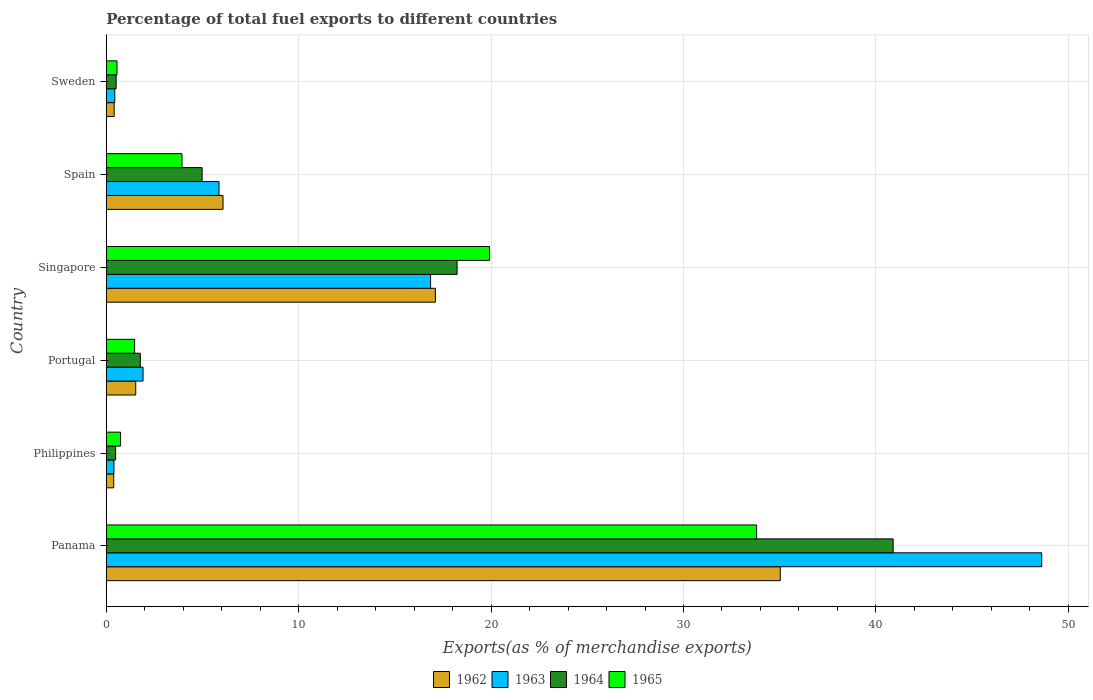How many groups of bars are there?
Offer a very short reply. 6. Are the number of bars per tick equal to the number of legend labels?
Make the answer very short. Yes. How many bars are there on the 5th tick from the bottom?
Keep it short and to the point. 4. What is the label of the 6th group of bars from the top?
Keep it short and to the point. Panama. What is the percentage of exports to different countries in 1963 in Panama?
Offer a very short reply. 48.62. Across all countries, what is the maximum percentage of exports to different countries in 1965?
Ensure brevity in your answer.  33.8. Across all countries, what is the minimum percentage of exports to different countries in 1962?
Ensure brevity in your answer.  0.38. In which country was the percentage of exports to different countries in 1962 maximum?
Your response must be concise. Panama. What is the total percentage of exports to different countries in 1965 in the graph?
Offer a very short reply. 60.42. What is the difference between the percentage of exports to different countries in 1964 in Portugal and that in Singapore?
Ensure brevity in your answer.  -16.47. What is the difference between the percentage of exports to different countries in 1962 in Panama and the percentage of exports to different countries in 1963 in Spain?
Give a very brief answer. 29.17. What is the average percentage of exports to different countries in 1962 per country?
Provide a short and direct response. 10.09. What is the difference between the percentage of exports to different countries in 1964 and percentage of exports to different countries in 1965 in Singapore?
Offer a very short reply. -1.69. What is the ratio of the percentage of exports to different countries in 1964 in Philippines to that in Singapore?
Give a very brief answer. 0.03. Is the difference between the percentage of exports to different countries in 1964 in Portugal and Sweden greater than the difference between the percentage of exports to different countries in 1965 in Portugal and Sweden?
Give a very brief answer. Yes. What is the difference between the highest and the second highest percentage of exports to different countries in 1963?
Your answer should be compact. 31.77. What is the difference between the highest and the lowest percentage of exports to different countries in 1962?
Keep it short and to the point. 34.64. In how many countries, is the percentage of exports to different countries in 1965 greater than the average percentage of exports to different countries in 1965 taken over all countries?
Provide a short and direct response. 2. Is it the case that in every country, the sum of the percentage of exports to different countries in 1964 and percentage of exports to different countries in 1963 is greater than the sum of percentage of exports to different countries in 1965 and percentage of exports to different countries in 1962?
Your answer should be compact. No. What does the 3rd bar from the top in Panama represents?
Provide a succinct answer. 1963. What does the 4th bar from the bottom in Portugal represents?
Your answer should be very brief. 1965. Is it the case that in every country, the sum of the percentage of exports to different countries in 1964 and percentage of exports to different countries in 1963 is greater than the percentage of exports to different countries in 1962?
Provide a succinct answer. Yes. How many bars are there?
Your response must be concise. 24. What is the difference between two consecutive major ticks on the X-axis?
Your response must be concise. 10. Are the values on the major ticks of X-axis written in scientific E-notation?
Your response must be concise. No. Does the graph contain any zero values?
Provide a succinct answer. No. Does the graph contain grids?
Give a very brief answer. Yes. How are the legend labels stacked?
Provide a short and direct response. Horizontal. What is the title of the graph?
Give a very brief answer. Percentage of total fuel exports to different countries. Does "2010" appear as one of the legend labels in the graph?
Keep it short and to the point. No. What is the label or title of the X-axis?
Your answer should be very brief. Exports(as % of merchandise exports). What is the label or title of the Y-axis?
Ensure brevity in your answer.  Country. What is the Exports(as % of merchandise exports) of 1962 in Panama?
Ensure brevity in your answer.  35.03. What is the Exports(as % of merchandise exports) in 1963 in Panama?
Keep it short and to the point. 48.62. What is the Exports(as % of merchandise exports) of 1964 in Panama?
Your answer should be compact. 40.9. What is the Exports(as % of merchandise exports) of 1965 in Panama?
Keep it short and to the point. 33.8. What is the Exports(as % of merchandise exports) in 1962 in Philippines?
Keep it short and to the point. 0.38. What is the Exports(as % of merchandise exports) in 1963 in Philippines?
Provide a short and direct response. 0.4. What is the Exports(as % of merchandise exports) of 1964 in Philippines?
Make the answer very short. 0.48. What is the Exports(as % of merchandise exports) of 1965 in Philippines?
Offer a terse response. 0.74. What is the Exports(as % of merchandise exports) in 1962 in Portugal?
Offer a terse response. 1.53. What is the Exports(as % of merchandise exports) in 1963 in Portugal?
Keep it short and to the point. 1.91. What is the Exports(as % of merchandise exports) in 1964 in Portugal?
Make the answer very short. 1.77. What is the Exports(as % of merchandise exports) of 1965 in Portugal?
Give a very brief answer. 1.47. What is the Exports(as % of merchandise exports) in 1962 in Singapore?
Ensure brevity in your answer.  17.1. What is the Exports(as % of merchandise exports) of 1963 in Singapore?
Keep it short and to the point. 16.85. What is the Exports(as % of merchandise exports) of 1964 in Singapore?
Your response must be concise. 18.23. What is the Exports(as % of merchandise exports) in 1965 in Singapore?
Provide a short and direct response. 19.92. What is the Exports(as % of merchandise exports) of 1962 in Spain?
Make the answer very short. 6.07. What is the Exports(as % of merchandise exports) of 1963 in Spain?
Make the answer very short. 5.86. What is the Exports(as % of merchandise exports) of 1964 in Spain?
Your answer should be very brief. 4.98. What is the Exports(as % of merchandise exports) of 1965 in Spain?
Keep it short and to the point. 3.93. What is the Exports(as % of merchandise exports) of 1962 in Sweden?
Ensure brevity in your answer.  0.41. What is the Exports(as % of merchandise exports) in 1963 in Sweden?
Provide a short and direct response. 0.44. What is the Exports(as % of merchandise exports) of 1964 in Sweden?
Make the answer very short. 0.51. What is the Exports(as % of merchandise exports) of 1965 in Sweden?
Your answer should be compact. 0.55. Across all countries, what is the maximum Exports(as % of merchandise exports) in 1962?
Your answer should be compact. 35.03. Across all countries, what is the maximum Exports(as % of merchandise exports) in 1963?
Provide a succinct answer. 48.62. Across all countries, what is the maximum Exports(as % of merchandise exports) in 1964?
Give a very brief answer. 40.9. Across all countries, what is the maximum Exports(as % of merchandise exports) in 1965?
Keep it short and to the point. 33.8. Across all countries, what is the minimum Exports(as % of merchandise exports) in 1962?
Offer a terse response. 0.38. Across all countries, what is the minimum Exports(as % of merchandise exports) in 1963?
Make the answer very short. 0.4. Across all countries, what is the minimum Exports(as % of merchandise exports) in 1964?
Your answer should be very brief. 0.48. Across all countries, what is the minimum Exports(as % of merchandise exports) of 1965?
Your answer should be very brief. 0.55. What is the total Exports(as % of merchandise exports) of 1962 in the graph?
Make the answer very short. 60.52. What is the total Exports(as % of merchandise exports) of 1963 in the graph?
Your response must be concise. 74.08. What is the total Exports(as % of merchandise exports) of 1964 in the graph?
Your answer should be very brief. 66.87. What is the total Exports(as % of merchandise exports) of 1965 in the graph?
Keep it short and to the point. 60.42. What is the difference between the Exports(as % of merchandise exports) of 1962 in Panama and that in Philippines?
Offer a terse response. 34.65. What is the difference between the Exports(as % of merchandise exports) in 1963 in Panama and that in Philippines?
Keep it short and to the point. 48.22. What is the difference between the Exports(as % of merchandise exports) of 1964 in Panama and that in Philippines?
Offer a very short reply. 40.41. What is the difference between the Exports(as % of merchandise exports) in 1965 in Panama and that in Philippines?
Keep it short and to the point. 33.06. What is the difference between the Exports(as % of merchandise exports) in 1962 in Panama and that in Portugal?
Your answer should be very brief. 33.5. What is the difference between the Exports(as % of merchandise exports) in 1963 in Panama and that in Portugal?
Give a very brief answer. 46.71. What is the difference between the Exports(as % of merchandise exports) in 1964 in Panama and that in Portugal?
Offer a very short reply. 39.13. What is the difference between the Exports(as % of merchandise exports) of 1965 in Panama and that in Portugal?
Make the answer very short. 32.33. What is the difference between the Exports(as % of merchandise exports) in 1962 in Panama and that in Singapore?
Offer a very short reply. 17.93. What is the difference between the Exports(as % of merchandise exports) in 1963 in Panama and that in Singapore?
Your answer should be very brief. 31.77. What is the difference between the Exports(as % of merchandise exports) in 1964 in Panama and that in Singapore?
Offer a very short reply. 22.67. What is the difference between the Exports(as % of merchandise exports) in 1965 in Panama and that in Singapore?
Offer a terse response. 13.88. What is the difference between the Exports(as % of merchandise exports) in 1962 in Panama and that in Spain?
Offer a very short reply. 28.96. What is the difference between the Exports(as % of merchandise exports) of 1963 in Panama and that in Spain?
Your response must be concise. 42.76. What is the difference between the Exports(as % of merchandise exports) in 1964 in Panama and that in Spain?
Your response must be concise. 35.92. What is the difference between the Exports(as % of merchandise exports) of 1965 in Panama and that in Spain?
Ensure brevity in your answer.  29.87. What is the difference between the Exports(as % of merchandise exports) of 1962 in Panama and that in Sweden?
Keep it short and to the point. 34.62. What is the difference between the Exports(as % of merchandise exports) in 1963 in Panama and that in Sweden?
Provide a succinct answer. 48.18. What is the difference between the Exports(as % of merchandise exports) in 1964 in Panama and that in Sweden?
Give a very brief answer. 40.39. What is the difference between the Exports(as % of merchandise exports) in 1965 in Panama and that in Sweden?
Provide a succinct answer. 33.25. What is the difference between the Exports(as % of merchandise exports) of 1962 in Philippines and that in Portugal?
Your response must be concise. -1.14. What is the difference between the Exports(as % of merchandise exports) of 1963 in Philippines and that in Portugal?
Your answer should be very brief. -1.51. What is the difference between the Exports(as % of merchandise exports) of 1964 in Philippines and that in Portugal?
Provide a succinct answer. -1.28. What is the difference between the Exports(as % of merchandise exports) of 1965 in Philippines and that in Portugal?
Keep it short and to the point. -0.73. What is the difference between the Exports(as % of merchandise exports) of 1962 in Philippines and that in Singapore?
Provide a succinct answer. -16.72. What is the difference between the Exports(as % of merchandise exports) of 1963 in Philippines and that in Singapore?
Offer a very short reply. -16.46. What is the difference between the Exports(as % of merchandise exports) in 1964 in Philippines and that in Singapore?
Make the answer very short. -17.75. What is the difference between the Exports(as % of merchandise exports) in 1965 in Philippines and that in Singapore?
Offer a very short reply. -19.18. What is the difference between the Exports(as % of merchandise exports) of 1962 in Philippines and that in Spain?
Keep it short and to the point. -5.68. What is the difference between the Exports(as % of merchandise exports) in 1963 in Philippines and that in Spain?
Your answer should be very brief. -5.46. What is the difference between the Exports(as % of merchandise exports) of 1964 in Philippines and that in Spain?
Keep it short and to the point. -4.49. What is the difference between the Exports(as % of merchandise exports) of 1965 in Philippines and that in Spain?
Your response must be concise. -3.19. What is the difference between the Exports(as % of merchandise exports) of 1962 in Philippines and that in Sweden?
Give a very brief answer. -0.02. What is the difference between the Exports(as % of merchandise exports) of 1963 in Philippines and that in Sweden?
Your answer should be compact. -0.04. What is the difference between the Exports(as % of merchandise exports) in 1964 in Philippines and that in Sweden?
Offer a terse response. -0.03. What is the difference between the Exports(as % of merchandise exports) of 1965 in Philippines and that in Sweden?
Give a very brief answer. 0.19. What is the difference between the Exports(as % of merchandise exports) of 1962 in Portugal and that in Singapore?
Your answer should be very brief. -15.58. What is the difference between the Exports(as % of merchandise exports) of 1963 in Portugal and that in Singapore?
Offer a terse response. -14.95. What is the difference between the Exports(as % of merchandise exports) in 1964 in Portugal and that in Singapore?
Make the answer very short. -16.47. What is the difference between the Exports(as % of merchandise exports) of 1965 in Portugal and that in Singapore?
Your response must be concise. -18.45. What is the difference between the Exports(as % of merchandise exports) in 1962 in Portugal and that in Spain?
Your answer should be very brief. -4.54. What is the difference between the Exports(as % of merchandise exports) in 1963 in Portugal and that in Spain?
Make the answer very short. -3.95. What is the difference between the Exports(as % of merchandise exports) in 1964 in Portugal and that in Spain?
Make the answer very short. -3.21. What is the difference between the Exports(as % of merchandise exports) of 1965 in Portugal and that in Spain?
Offer a very short reply. -2.46. What is the difference between the Exports(as % of merchandise exports) of 1962 in Portugal and that in Sweden?
Provide a short and direct response. 1.12. What is the difference between the Exports(as % of merchandise exports) of 1963 in Portugal and that in Sweden?
Offer a terse response. 1.47. What is the difference between the Exports(as % of merchandise exports) in 1964 in Portugal and that in Sweden?
Your answer should be compact. 1.26. What is the difference between the Exports(as % of merchandise exports) in 1965 in Portugal and that in Sweden?
Offer a very short reply. 0.91. What is the difference between the Exports(as % of merchandise exports) in 1962 in Singapore and that in Spain?
Keep it short and to the point. 11.04. What is the difference between the Exports(as % of merchandise exports) of 1963 in Singapore and that in Spain?
Give a very brief answer. 11. What is the difference between the Exports(as % of merchandise exports) in 1964 in Singapore and that in Spain?
Provide a succinct answer. 13.25. What is the difference between the Exports(as % of merchandise exports) of 1965 in Singapore and that in Spain?
Give a very brief answer. 15.99. What is the difference between the Exports(as % of merchandise exports) in 1962 in Singapore and that in Sweden?
Offer a terse response. 16.7. What is the difference between the Exports(as % of merchandise exports) of 1963 in Singapore and that in Sweden?
Keep it short and to the point. 16.42. What is the difference between the Exports(as % of merchandise exports) in 1964 in Singapore and that in Sweden?
Make the answer very short. 17.72. What is the difference between the Exports(as % of merchandise exports) in 1965 in Singapore and that in Sweden?
Offer a very short reply. 19.37. What is the difference between the Exports(as % of merchandise exports) in 1962 in Spain and that in Sweden?
Provide a short and direct response. 5.66. What is the difference between the Exports(as % of merchandise exports) of 1963 in Spain and that in Sweden?
Offer a very short reply. 5.42. What is the difference between the Exports(as % of merchandise exports) in 1964 in Spain and that in Sweden?
Your answer should be compact. 4.47. What is the difference between the Exports(as % of merchandise exports) of 1965 in Spain and that in Sweden?
Offer a terse response. 3.38. What is the difference between the Exports(as % of merchandise exports) of 1962 in Panama and the Exports(as % of merchandise exports) of 1963 in Philippines?
Provide a short and direct response. 34.63. What is the difference between the Exports(as % of merchandise exports) in 1962 in Panama and the Exports(as % of merchandise exports) in 1964 in Philippines?
Offer a terse response. 34.55. What is the difference between the Exports(as % of merchandise exports) of 1962 in Panama and the Exports(as % of merchandise exports) of 1965 in Philippines?
Ensure brevity in your answer.  34.29. What is the difference between the Exports(as % of merchandise exports) in 1963 in Panama and the Exports(as % of merchandise exports) in 1964 in Philippines?
Ensure brevity in your answer.  48.14. What is the difference between the Exports(as % of merchandise exports) in 1963 in Panama and the Exports(as % of merchandise exports) in 1965 in Philippines?
Your answer should be compact. 47.88. What is the difference between the Exports(as % of merchandise exports) in 1964 in Panama and the Exports(as % of merchandise exports) in 1965 in Philippines?
Your answer should be very brief. 40.16. What is the difference between the Exports(as % of merchandise exports) in 1962 in Panama and the Exports(as % of merchandise exports) in 1963 in Portugal?
Keep it short and to the point. 33.12. What is the difference between the Exports(as % of merchandise exports) of 1962 in Panama and the Exports(as % of merchandise exports) of 1964 in Portugal?
Your answer should be compact. 33.26. What is the difference between the Exports(as % of merchandise exports) of 1962 in Panama and the Exports(as % of merchandise exports) of 1965 in Portugal?
Keep it short and to the point. 33.56. What is the difference between the Exports(as % of merchandise exports) in 1963 in Panama and the Exports(as % of merchandise exports) in 1964 in Portugal?
Your answer should be very brief. 46.85. What is the difference between the Exports(as % of merchandise exports) in 1963 in Panama and the Exports(as % of merchandise exports) in 1965 in Portugal?
Your response must be concise. 47.15. What is the difference between the Exports(as % of merchandise exports) in 1964 in Panama and the Exports(as % of merchandise exports) in 1965 in Portugal?
Make the answer very short. 39.43. What is the difference between the Exports(as % of merchandise exports) of 1962 in Panama and the Exports(as % of merchandise exports) of 1963 in Singapore?
Keep it short and to the point. 18.18. What is the difference between the Exports(as % of merchandise exports) of 1962 in Panama and the Exports(as % of merchandise exports) of 1964 in Singapore?
Give a very brief answer. 16.8. What is the difference between the Exports(as % of merchandise exports) of 1962 in Panama and the Exports(as % of merchandise exports) of 1965 in Singapore?
Make the answer very short. 15.11. What is the difference between the Exports(as % of merchandise exports) in 1963 in Panama and the Exports(as % of merchandise exports) in 1964 in Singapore?
Your answer should be very brief. 30.39. What is the difference between the Exports(as % of merchandise exports) in 1963 in Panama and the Exports(as % of merchandise exports) in 1965 in Singapore?
Offer a terse response. 28.7. What is the difference between the Exports(as % of merchandise exports) in 1964 in Panama and the Exports(as % of merchandise exports) in 1965 in Singapore?
Make the answer very short. 20.98. What is the difference between the Exports(as % of merchandise exports) of 1962 in Panama and the Exports(as % of merchandise exports) of 1963 in Spain?
Your answer should be very brief. 29.17. What is the difference between the Exports(as % of merchandise exports) in 1962 in Panama and the Exports(as % of merchandise exports) in 1964 in Spain?
Make the answer very short. 30.05. What is the difference between the Exports(as % of merchandise exports) of 1962 in Panama and the Exports(as % of merchandise exports) of 1965 in Spain?
Make the answer very short. 31.1. What is the difference between the Exports(as % of merchandise exports) of 1963 in Panama and the Exports(as % of merchandise exports) of 1964 in Spain?
Provide a short and direct response. 43.64. What is the difference between the Exports(as % of merchandise exports) of 1963 in Panama and the Exports(as % of merchandise exports) of 1965 in Spain?
Give a very brief answer. 44.69. What is the difference between the Exports(as % of merchandise exports) in 1964 in Panama and the Exports(as % of merchandise exports) in 1965 in Spain?
Your answer should be very brief. 36.96. What is the difference between the Exports(as % of merchandise exports) in 1962 in Panama and the Exports(as % of merchandise exports) in 1963 in Sweden?
Give a very brief answer. 34.59. What is the difference between the Exports(as % of merchandise exports) in 1962 in Panama and the Exports(as % of merchandise exports) in 1964 in Sweden?
Offer a very short reply. 34.52. What is the difference between the Exports(as % of merchandise exports) of 1962 in Panama and the Exports(as % of merchandise exports) of 1965 in Sweden?
Your answer should be compact. 34.48. What is the difference between the Exports(as % of merchandise exports) in 1963 in Panama and the Exports(as % of merchandise exports) in 1964 in Sweden?
Your response must be concise. 48.11. What is the difference between the Exports(as % of merchandise exports) of 1963 in Panama and the Exports(as % of merchandise exports) of 1965 in Sweden?
Provide a succinct answer. 48.07. What is the difference between the Exports(as % of merchandise exports) in 1964 in Panama and the Exports(as % of merchandise exports) in 1965 in Sweden?
Keep it short and to the point. 40.34. What is the difference between the Exports(as % of merchandise exports) in 1962 in Philippines and the Exports(as % of merchandise exports) in 1963 in Portugal?
Your response must be concise. -1.52. What is the difference between the Exports(as % of merchandise exports) in 1962 in Philippines and the Exports(as % of merchandise exports) in 1964 in Portugal?
Your answer should be very brief. -1.38. What is the difference between the Exports(as % of merchandise exports) in 1962 in Philippines and the Exports(as % of merchandise exports) in 1965 in Portugal?
Keep it short and to the point. -1.08. What is the difference between the Exports(as % of merchandise exports) of 1963 in Philippines and the Exports(as % of merchandise exports) of 1964 in Portugal?
Offer a terse response. -1.37. What is the difference between the Exports(as % of merchandise exports) in 1963 in Philippines and the Exports(as % of merchandise exports) in 1965 in Portugal?
Provide a succinct answer. -1.07. What is the difference between the Exports(as % of merchandise exports) of 1964 in Philippines and the Exports(as % of merchandise exports) of 1965 in Portugal?
Your response must be concise. -0.99. What is the difference between the Exports(as % of merchandise exports) of 1962 in Philippines and the Exports(as % of merchandise exports) of 1963 in Singapore?
Provide a short and direct response. -16.47. What is the difference between the Exports(as % of merchandise exports) in 1962 in Philippines and the Exports(as % of merchandise exports) in 1964 in Singapore?
Keep it short and to the point. -17.85. What is the difference between the Exports(as % of merchandise exports) in 1962 in Philippines and the Exports(as % of merchandise exports) in 1965 in Singapore?
Give a very brief answer. -19.54. What is the difference between the Exports(as % of merchandise exports) in 1963 in Philippines and the Exports(as % of merchandise exports) in 1964 in Singapore?
Your answer should be very brief. -17.84. What is the difference between the Exports(as % of merchandise exports) of 1963 in Philippines and the Exports(as % of merchandise exports) of 1965 in Singapore?
Make the answer very short. -19.53. What is the difference between the Exports(as % of merchandise exports) in 1964 in Philippines and the Exports(as % of merchandise exports) in 1965 in Singapore?
Offer a terse response. -19.44. What is the difference between the Exports(as % of merchandise exports) of 1962 in Philippines and the Exports(as % of merchandise exports) of 1963 in Spain?
Your answer should be compact. -5.47. What is the difference between the Exports(as % of merchandise exports) of 1962 in Philippines and the Exports(as % of merchandise exports) of 1964 in Spain?
Make the answer very short. -4.59. What is the difference between the Exports(as % of merchandise exports) of 1962 in Philippines and the Exports(as % of merchandise exports) of 1965 in Spain?
Make the answer very short. -3.55. What is the difference between the Exports(as % of merchandise exports) of 1963 in Philippines and the Exports(as % of merchandise exports) of 1964 in Spain?
Offer a very short reply. -4.58. What is the difference between the Exports(as % of merchandise exports) of 1963 in Philippines and the Exports(as % of merchandise exports) of 1965 in Spain?
Provide a short and direct response. -3.54. What is the difference between the Exports(as % of merchandise exports) in 1964 in Philippines and the Exports(as % of merchandise exports) in 1965 in Spain?
Your answer should be compact. -3.45. What is the difference between the Exports(as % of merchandise exports) in 1962 in Philippines and the Exports(as % of merchandise exports) in 1963 in Sweden?
Make the answer very short. -0.05. What is the difference between the Exports(as % of merchandise exports) of 1962 in Philippines and the Exports(as % of merchandise exports) of 1964 in Sweden?
Your answer should be compact. -0.13. What is the difference between the Exports(as % of merchandise exports) in 1962 in Philippines and the Exports(as % of merchandise exports) in 1965 in Sweden?
Your response must be concise. -0.17. What is the difference between the Exports(as % of merchandise exports) in 1963 in Philippines and the Exports(as % of merchandise exports) in 1964 in Sweden?
Offer a very short reply. -0.11. What is the difference between the Exports(as % of merchandise exports) of 1963 in Philippines and the Exports(as % of merchandise exports) of 1965 in Sweden?
Make the answer very short. -0.16. What is the difference between the Exports(as % of merchandise exports) in 1964 in Philippines and the Exports(as % of merchandise exports) in 1965 in Sweden?
Keep it short and to the point. -0.07. What is the difference between the Exports(as % of merchandise exports) of 1962 in Portugal and the Exports(as % of merchandise exports) of 1963 in Singapore?
Offer a terse response. -15.33. What is the difference between the Exports(as % of merchandise exports) of 1962 in Portugal and the Exports(as % of merchandise exports) of 1964 in Singapore?
Your answer should be compact. -16.7. What is the difference between the Exports(as % of merchandise exports) of 1962 in Portugal and the Exports(as % of merchandise exports) of 1965 in Singapore?
Give a very brief answer. -18.39. What is the difference between the Exports(as % of merchandise exports) in 1963 in Portugal and the Exports(as % of merchandise exports) in 1964 in Singapore?
Your answer should be compact. -16.32. What is the difference between the Exports(as % of merchandise exports) in 1963 in Portugal and the Exports(as % of merchandise exports) in 1965 in Singapore?
Provide a succinct answer. -18.01. What is the difference between the Exports(as % of merchandise exports) of 1964 in Portugal and the Exports(as % of merchandise exports) of 1965 in Singapore?
Ensure brevity in your answer.  -18.16. What is the difference between the Exports(as % of merchandise exports) of 1962 in Portugal and the Exports(as % of merchandise exports) of 1963 in Spain?
Make the answer very short. -4.33. What is the difference between the Exports(as % of merchandise exports) in 1962 in Portugal and the Exports(as % of merchandise exports) in 1964 in Spain?
Ensure brevity in your answer.  -3.45. What is the difference between the Exports(as % of merchandise exports) of 1962 in Portugal and the Exports(as % of merchandise exports) of 1965 in Spain?
Make the answer very short. -2.41. What is the difference between the Exports(as % of merchandise exports) in 1963 in Portugal and the Exports(as % of merchandise exports) in 1964 in Spain?
Keep it short and to the point. -3.07. What is the difference between the Exports(as % of merchandise exports) of 1963 in Portugal and the Exports(as % of merchandise exports) of 1965 in Spain?
Offer a very short reply. -2.03. What is the difference between the Exports(as % of merchandise exports) of 1964 in Portugal and the Exports(as % of merchandise exports) of 1965 in Spain?
Your answer should be very brief. -2.17. What is the difference between the Exports(as % of merchandise exports) of 1962 in Portugal and the Exports(as % of merchandise exports) of 1963 in Sweden?
Provide a succinct answer. 1.09. What is the difference between the Exports(as % of merchandise exports) of 1962 in Portugal and the Exports(as % of merchandise exports) of 1964 in Sweden?
Your answer should be very brief. 1.02. What is the difference between the Exports(as % of merchandise exports) in 1962 in Portugal and the Exports(as % of merchandise exports) in 1965 in Sweden?
Ensure brevity in your answer.  0.97. What is the difference between the Exports(as % of merchandise exports) in 1963 in Portugal and the Exports(as % of merchandise exports) in 1964 in Sweden?
Offer a terse response. 1.4. What is the difference between the Exports(as % of merchandise exports) of 1963 in Portugal and the Exports(as % of merchandise exports) of 1965 in Sweden?
Make the answer very short. 1.35. What is the difference between the Exports(as % of merchandise exports) in 1964 in Portugal and the Exports(as % of merchandise exports) in 1965 in Sweden?
Provide a succinct answer. 1.21. What is the difference between the Exports(as % of merchandise exports) of 1962 in Singapore and the Exports(as % of merchandise exports) of 1963 in Spain?
Offer a very short reply. 11.25. What is the difference between the Exports(as % of merchandise exports) in 1962 in Singapore and the Exports(as % of merchandise exports) in 1964 in Spain?
Give a very brief answer. 12.13. What is the difference between the Exports(as % of merchandise exports) in 1962 in Singapore and the Exports(as % of merchandise exports) in 1965 in Spain?
Offer a very short reply. 13.17. What is the difference between the Exports(as % of merchandise exports) in 1963 in Singapore and the Exports(as % of merchandise exports) in 1964 in Spain?
Keep it short and to the point. 11.88. What is the difference between the Exports(as % of merchandise exports) of 1963 in Singapore and the Exports(as % of merchandise exports) of 1965 in Spain?
Make the answer very short. 12.92. What is the difference between the Exports(as % of merchandise exports) in 1964 in Singapore and the Exports(as % of merchandise exports) in 1965 in Spain?
Ensure brevity in your answer.  14.3. What is the difference between the Exports(as % of merchandise exports) of 1962 in Singapore and the Exports(as % of merchandise exports) of 1963 in Sweden?
Give a very brief answer. 16.66. What is the difference between the Exports(as % of merchandise exports) of 1962 in Singapore and the Exports(as % of merchandise exports) of 1964 in Sweden?
Your answer should be very brief. 16.59. What is the difference between the Exports(as % of merchandise exports) in 1962 in Singapore and the Exports(as % of merchandise exports) in 1965 in Sweden?
Make the answer very short. 16.55. What is the difference between the Exports(as % of merchandise exports) of 1963 in Singapore and the Exports(as % of merchandise exports) of 1964 in Sweden?
Provide a short and direct response. 16.34. What is the difference between the Exports(as % of merchandise exports) in 1963 in Singapore and the Exports(as % of merchandise exports) in 1965 in Sweden?
Ensure brevity in your answer.  16.3. What is the difference between the Exports(as % of merchandise exports) in 1964 in Singapore and the Exports(as % of merchandise exports) in 1965 in Sweden?
Provide a succinct answer. 17.68. What is the difference between the Exports(as % of merchandise exports) in 1962 in Spain and the Exports(as % of merchandise exports) in 1963 in Sweden?
Your response must be concise. 5.63. What is the difference between the Exports(as % of merchandise exports) of 1962 in Spain and the Exports(as % of merchandise exports) of 1964 in Sweden?
Make the answer very short. 5.56. What is the difference between the Exports(as % of merchandise exports) of 1962 in Spain and the Exports(as % of merchandise exports) of 1965 in Sweden?
Give a very brief answer. 5.51. What is the difference between the Exports(as % of merchandise exports) in 1963 in Spain and the Exports(as % of merchandise exports) in 1964 in Sweden?
Provide a short and direct response. 5.35. What is the difference between the Exports(as % of merchandise exports) of 1963 in Spain and the Exports(as % of merchandise exports) of 1965 in Sweden?
Your response must be concise. 5.3. What is the difference between the Exports(as % of merchandise exports) of 1964 in Spain and the Exports(as % of merchandise exports) of 1965 in Sweden?
Provide a short and direct response. 4.42. What is the average Exports(as % of merchandise exports) in 1962 per country?
Offer a very short reply. 10.09. What is the average Exports(as % of merchandise exports) in 1963 per country?
Your response must be concise. 12.35. What is the average Exports(as % of merchandise exports) in 1964 per country?
Offer a very short reply. 11.14. What is the average Exports(as % of merchandise exports) of 1965 per country?
Ensure brevity in your answer.  10.07. What is the difference between the Exports(as % of merchandise exports) in 1962 and Exports(as % of merchandise exports) in 1963 in Panama?
Ensure brevity in your answer.  -13.59. What is the difference between the Exports(as % of merchandise exports) of 1962 and Exports(as % of merchandise exports) of 1964 in Panama?
Provide a short and direct response. -5.87. What is the difference between the Exports(as % of merchandise exports) in 1962 and Exports(as % of merchandise exports) in 1965 in Panama?
Keep it short and to the point. 1.23. What is the difference between the Exports(as % of merchandise exports) of 1963 and Exports(as % of merchandise exports) of 1964 in Panama?
Your response must be concise. 7.72. What is the difference between the Exports(as % of merchandise exports) of 1963 and Exports(as % of merchandise exports) of 1965 in Panama?
Keep it short and to the point. 14.82. What is the difference between the Exports(as % of merchandise exports) of 1964 and Exports(as % of merchandise exports) of 1965 in Panama?
Offer a very short reply. 7.1. What is the difference between the Exports(as % of merchandise exports) of 1962 and Exports(as % of merchandise exports) of 1963 in Philippines?
Provide a succinct answer. -0.01. What is the difference between the Exports(as % of merchandise exports) of 1962 and Exports(as % of merchandise exports) of 1964 in Philippines?
Your answer should be very brief. -0.1. What is the difference between the Exports(as % of merchandise exports) of 1962 and Exports(as % of merchandise exports) of 1965 in Philippines?
Your response must be concise. -0.35. What is the difference between the Exports(as % of merchandise exports) of 1963 and Exports(as % of merchandise exports) of 1964 in Philippines?
Your response must be concise. -0.09. What is the difference between the Exports(as % of merchandise exports) of 1963 and Exports(as % of merchandise exports) of 1965 in Philippines?
Keep it short and to the point. -0.34. What is the difference between the Exports(as % of merchandise exports) of 1964 and Exports(as % of merchandise exports) of 1965 in Philippines?
Provide a short and direct response. -0.26. What is the difference between the Exports(as % of merchandise exports) of 1962 and Exports(as % of merchandise exports) of 1963 in Portugal?
Ensure brevity in your answer.  -0.38. What is the difference between the Exports(as % of merchandise exports) of 1962 and Exports(as % of merchandise exports) of 1964 in Portugal?
Ensure brevity in your answer.  -0.24. What is the difference between the Exports(as % of merchandise exports) in 1962 and Exports(as % of merchandise exports) in 1965 in Portugal?
Your answer should be very brief. 0.06. What is the difference between the Exports(as % of merchandise exports) in 1963 and Exports(as % of merchandise exports) in 1964 in Portugal?
Your answer should be very brief. 0.14. What is the difference between the Exports(as % of merchandise exports) in 1963 and Exports(as % of merchandise exports) in 1965 in Portugal?
Your answer should be compact. 0.44. What is the difference between the Exports(as % of merchandise exports) of 1964 and Exports(as % of merchandise exports) of 1965 in Portugal?
Your answer should be compact. 0.3. What is the difference between the Exports(as % of merchandise exports) of 1962 and Exports(as % of merchandise exports) of 1963 in Singapore?
Provide a succinct answer. 0.25. What is the difference between the Exports(as % of merchandise exports) in 1962 and Exports(as % of merchandise exports) in 1964 in Singapore?
Provide a succinct answer. -1.13. What is the difference between the Exports(as % of merchandise exports) in 1962 and Exports(as % of merchandise exports) in 1965 in Singapore?
Your answer should be very brief. -2.82. What is the difference between the Exports(as % of merchandise exports) in 1963 and Exports(as % of merchandise exports) in 1964 in Singapore?
Provide a succinct answer. -1.38. What is the difference between the Exports(as % of merchandise exports) in 1963 and Exports(as % of merchandise exports) in 1965 in Singapore?
Give a very brief answer. -3.07. What is the difference between the Exports(as % of merchandise exports) of 1964 and Exports(as % of merchandise exports) of 1965 in Singapore?
Offer a very short reply. -1.69. What is the difference between the Exports(as % of merchandise exports) of 1962 and Exports(as % of merchandise exports) of 1963 in Spain?
Your answer should be very brief. 0.21. What is the difference between the Exports(as % of merchandise exports) in 1962 and Exports(as % of merchandise exports) in 1964 in Spain?
Offer a terse response. 1.09. What is the difference between the Exports(as % of merchandise exports) of 1962 and Exports(as % of merchandise exports) of 1965 in Spain?
Provide a succinct answer. 2.13. What is the difference between the Exports(as % of merchandise exports) of 1963 and Exports(as % of merchandise exports) of 1964 in Spain?
Give a very brief answer. 0.88. What is the difference between the Exports(as % of merchandise exports) of 1963 and Exports(as % of merchandise exports) of 1965 in Spain?
Provide a succinct answer. 1.92. What is the difference between the Exports(as % of merchandise exports) in 1964 and Exports(as % of merchandise exports) in 1965 in Spain?
Make the answer very short. 1.04. What is the difference between the Exports(as % of merchandise exports) of 1962 and Exports(as % of merchandise exports) of 1963 in Sweden?
Your response must be concise. -0.03. What is the difference between the Exports(as % of merchandise exports) of 1962 and Exports(as % of merchandise exports) of 1964 in Sweden?
Offer a very short reply. -0.1. What is the difference between the Exports(as % of merchandise exports) of 1962 and Exports(as % of merchandise exports) of 1965 in Sweden?
Make the answer very short. -0.15. What is the difference between the Exports(as % of merchandise exports) in 1963 and Exports(as % of merchandise exports) in 1964 in Sweden?
Keep it short and to the point. -0.07. What is the difference between the Exports(as % of merchandise exports) of 1963 and Exports(as % of merchandise exports) of 1965 in Sweden?
Offer a terse response. -0.12. What is the difference between the Exports(as % of merchandise exports) of 1964 and Exports(as % of merchandise exports) of 1965 in Sweden?
Your answer should be compact. -0.04. What is the ratio of the Exports(as % of merchandise exports) in 1962 in Panama to that in Philippines?
Keep it short and to the point. 91.01. What is the ratio of the Exports(as % of merchandise exports) of 1963 in Panama to that in Philippines?
Give a very brief answer. 122.82. What is the ratio of the Exports(as % of merchandise exports) in 1964 in Panama to that in Philippines?
Your answer should be very brief. 84.6. What is the ratio of the Exports(as % of merchandise exports) in 1965 in Panama to that in Philippines?
Your answer should be very brief. 45.69. What is the ratio of the Exports(as % of merchandise exports) in 1962 in Panama to that in Portugal?
Offer a terse response. 22.92. What is the ratio of the Exports(as % of merchandise exports) in 1963 in Panama to that in Portugal?
Provide a short and direct response. 25.47. What is the ratio of the Exports(as % of merchandise exports) in 1964 in Panama to that in Portugal?
Offer a terse response. 23.15. What is the ratio of the Exports(as % of merchandise exports) in 1965 in Panama to that in Portugal?
Ensure brevity in your answer.  23. What is the ratio of the Exports(as % of merchandise exports) in 1962 in Panama to that in Singapore?
Give a very brief answer. 2.05. What is the ratio of the Exports(as % of merchandise exports) of 1963 in Panama to that in Singapore?
Keep it short and to the point. 2.88. What is the ratio of the Exports(as % of merchandise exports) in 1964 in Panama to that in Singapore?
Ensure brevity in your answer.  2.24. What is the ratio of the Exports(as % of merchandise exports) of 1965 in Panama to that in Singapore?
Ensure brevity in your answer.  1.7. What is the ratio of the Exports(as % of merchandise exports) in 1962 in Panama to that in Spain?
Make the answer very short. 5.77. What is the ratio of the Exports(as % of merchandise exports) of 1963 in Panama to that in Spain?
Provide a succinct answer. 8.3. What is the ratio of the Exports(as % of merchandise exports) in 1964 in Panama to that in Spain?
Your response must be concise. 8.22. What is the ratio of the Exports(as % of merchandise exports) of 1965 in Panama to that in Spain?
Offer a terse response. 8.59. What is the ratio of the Exports(as % of merchandise exports) of 1962 in Panama to that in Sweden?
Keep it short and to the point. 86. What is the ratio of the Exports(as % of merchandise exports) in 1963 in Panama to that in Sweden?
Your answer should be very brief. 110.64. What is the ratio of the Exports(as % of merchandise exports) in 1964 in Panama to that in Sweden?
Ensure brevity in your answer.  80.13. What is the ratio of the Exports(as % of merchandise exports) of 1965 in Panama to that in Sweden?
Offer a terse response. 60.94. What is the ratio of the Exports(as % of merchandise exports) of 1962 in Philippines to that in Portugal?
Offer a terse response. 0.25. What is the ratio of the Exports(as % of merchandise exports) in 1963 in Philippines to that in Portugal?
Provide a succinct answer. 0.21. What is the ratio of the Exports(as % of merchandise exports) of 1964 in Philippines to that in Portugal?
Provide a succinct answer. 0.27. What is the ratio of the Exports(as % of merchandise exports) in 1965 in Philippines to that in Portugal?
Make the answer very short. 0.5. What is the ratio of the Exports(as % of merchandise exports) in 1962 in Philippines to that in Singapore?
Ensure brevity in your answer.  0.02. What is the ratio of the Exports(as % of merchandise exports) of 1963 in Philippines to that in Singapore?
Give a very brief answer. 0.02. What is the ratio of the Exports(as % of merchandise exports) of 1964 in Philippines to that in Singapore?
Your response must be concise. 0.03. What is the ratio of the Exports(as % of merchandise exports) in 1965 in Philippines to that in Singapore?
Offer a very short reply. 0.04. What is the ratio of the Exports(as % of merchandise exports) in 1962 in Philippines to that in Spain?
Provide a short and direct response. 0.06. What is the ratio of the Exports(as % of merchandise exports) of 1963 in Philippines to that in Spain?
Provide a succinct answer. 0.07. What is the ratio of the Exports(as % of merchandise exports) in 1964 in Philippines to that in Spain?
Keep it short and to the point. 0.1. What is the ratio of the Exports(as % of merchandise exports) of 1965 in Philippines to that in Spain?
Keep it short and to the point. 0.19. What is the ratio of the Exports(as % of merchandise exports) of 1962 in Philippines to that in Sweden?
Provide a short and direct response. 0.94. What is the ratio of the Exports(as % of merchandise exports) of 1963 in Philippines to that in Sweden?
Provide a short and direct response. 0.9. What is the ratio of the Exports(as % of merchandise exports) of 1964 in Philippines to that in Sweden?
Give a very brief answer. 0.95. What is the ratio of the Exports(as % of merchandise exports) in 1965 in Philippines to that in Sweden?
Your answer should be very brief. 1.33. What is the ratio of the Exports(as % of merchandise exports) of 1962 in Portugal to that in Singapore?
Your response must be concise. 0.09. What is the ratio of the Exports(as % of merchandise exports) in 1963 in Portugal to that in Singapore?
Provide a short and direct response. 0.11. What is the ratio of the Exports(as % of merchandise exports) of 1964 in Portugal to that in Singapore?
Offer a terse response. 0.1. What is the ratio of the Exports(as % of merchandise exports) of 1965 in Portugal to that in Singapore?
Your answer should be compact. 0.07. What is the ratio of the Exports(as % of merchandise exports) in 1962 in Portugal to that in Spain?
Make the answer very short. 0.25. What is the ratio of the Exports(as % of merchandise exports) of 1963 in Portugal to that in Spain?
Give a very brief answer. 0.33. What is the ratio of the Exports(as % of merchandise exports) in 1964 in Portugal to that in Spain?
Ensure brevity in your answer.  0.35. What is the ratio of the Exports(as % of merchandise exports) of 1965 in Portugal to that in Spain?
Provide a succinct answer. 0.37. What is the ratio of the Exports(as % of merchandise exports) in 1962 in Portugal to that in Sweden?
Offer a terse response. 3.75. What is the ratio of the Exports(as % of merchandise exports) of 1963 in Portugal to that in Sweden?
Provide a succinct answer. 4.34. What is the ratio of the Exports(as % of merchandise exports) of 1964 in Portugal to that in Sweden?
Give a very brief answer. 3.46. What is the ratio of the Exports(as % of merchandise exports) of 1965 in Portugal to that in Sweden?
Your answer should be compact. 2.65. What is the ratio of the Exports(as % of merchandise exports) in 1962 in Singapore to that in Spain?
Your answer should be very brief. 2.82. What is the ratio of the Exports(as % of merchandise exports) of 1963 in Singapore to that in Spain?
Give a very brief answer. 2.88. What is the ratio of the Exports(as % of merchandise exports) of 1964 in Singapore to that in Spain?
Ensure brevity in your answer.  3.66. What is the ratio of the Exports(as % of merchandise exports) of 1965 in Singapore to that in Spain?
Your answer should be very brief. 5.06. What is the ratio of the Exports(as % of merchandise exports) in 1962 in Singapore to that in Sweden?
Give a very brief answer. 41.99. What is the ratio of the Exports(as % of merchandise exports) of 1963 in Singapore to that in Sweden?
Provide a short and direct response. 38.35. What is the ratio of the Exports(as % of merchandise exports) in 1964 in Singapore to that in Sweden?
Your answer should be very brief. 35.72. What is the ratio of the Exports(as % of merchandise exports) in 1965 in Singapore to that in Sweden?
Keep it short and to the point. 35.92. What is the ratio of the Exports(as % of merchandise exports) in 1962 in Spain to that in Sweden?
Your answer should be very brief. 14.89. What is the ratio of the Exports(as % of merchandise exports) of 1963 in Spain to that in Sweden?
Give a very brief answer. 13.33. What is the ratio of the Exports(as % of merchandise exports) of 1964 in Spain to that in Sweden?
Give a very brief answer. 9.75. What is the ratio of the Exports(as % of merchandise exports) in 1965 in Spain to that in Sweden?
Your response must be concise. 7.09. What is the difference between the highest and the second highest Exports(as % of merchandise exports) in 1962?
Make the answer very short. 17.93. What is the difference between the highest and the second highest Exports(as % of merchandise exports) in 1963?
Keep it short and to the point. 31.77. What is the difference between the highest and the second highest Exports(as % of merchandise exports) in 1964?
Your answer should be very brief. 22.67. What is the difference between the highest and the second highest Exports(as % of merchandise exports) in 1965?
Offer a terse response. 13.88. What is the difference between the highest and the lowest Exports(as % of merchandise exports) of 1962?
Your answer should be very brief. 34.65. What is the difference between the highest and the lowest Exports(as % of merchandise exports) in 1963?
Offer a terse response. 48.22. What is the difference between the highest and the lowest Exports(as % of merchandise exports) in 1964?
Keep it short and to the point. 40.41. What is the difference between the highest and the lowest Exports(as % of merchandise exports) of 1965?
Offer a terse response. 33.25. 